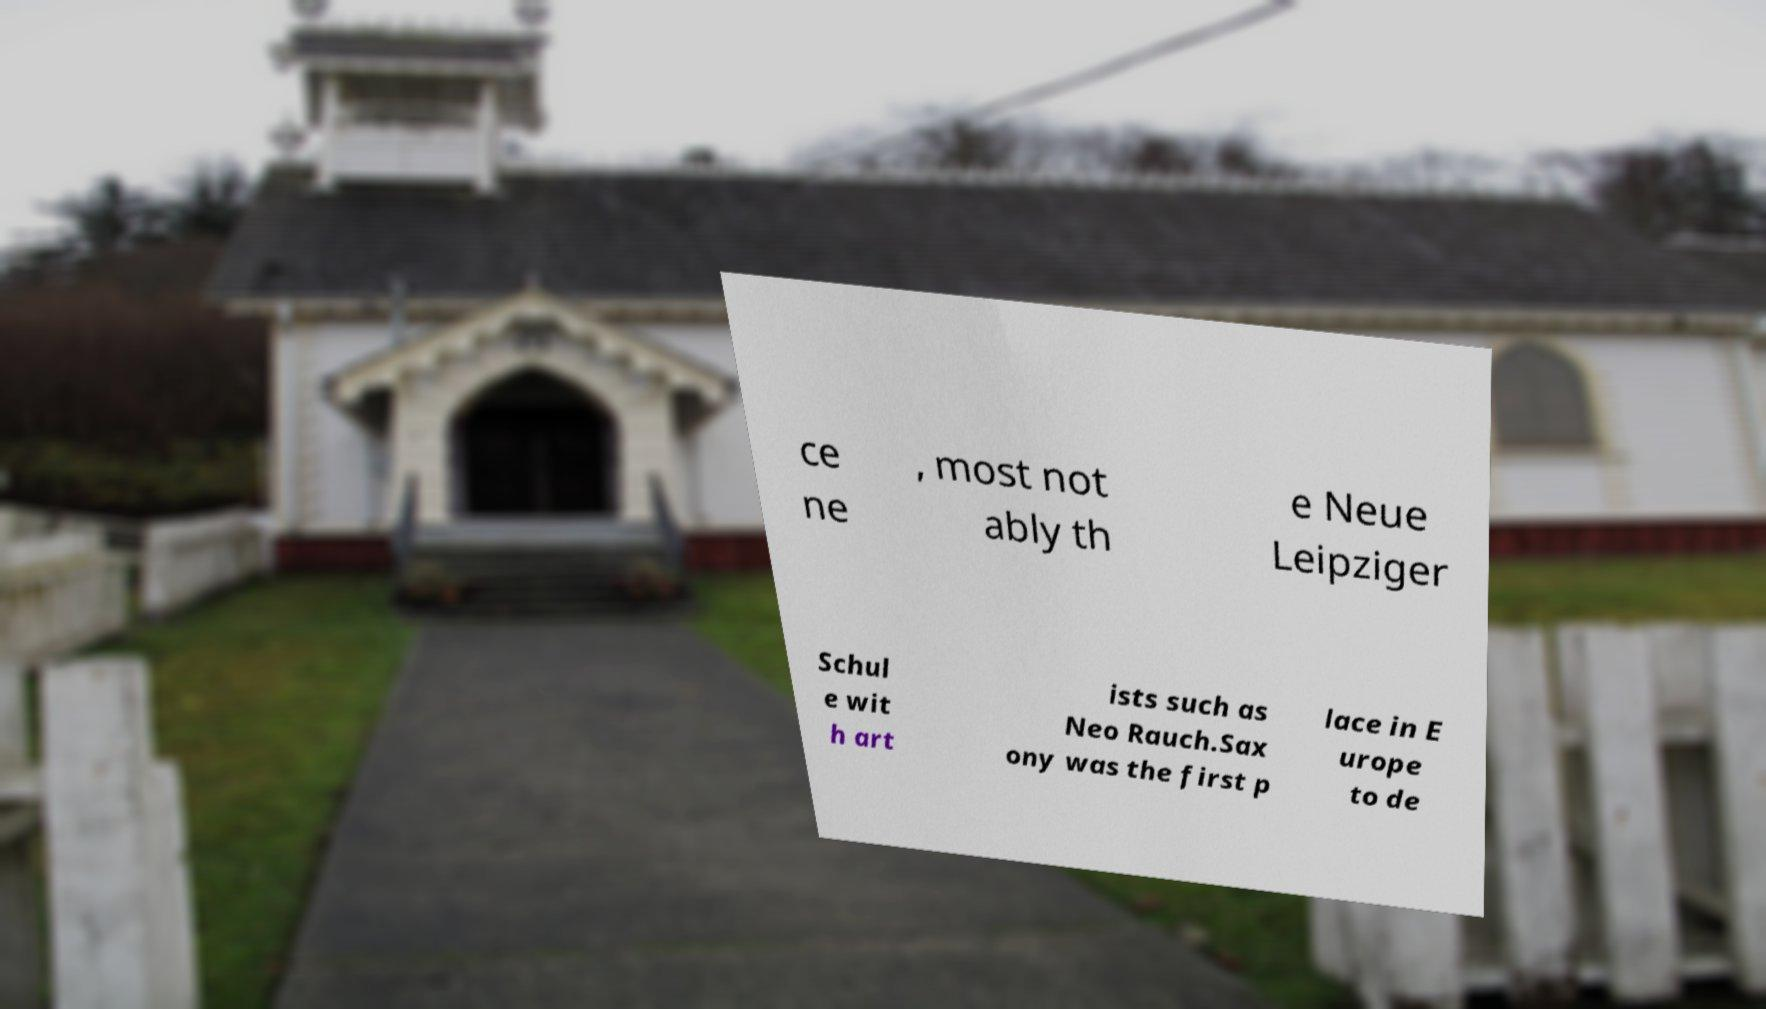Could you extract and type out the text from this image? ce ne , most not ably th e Neue Leipziger Schul e wit h art ists such as Neo Rauch.Sax ony was the first p lace in E urope to de 